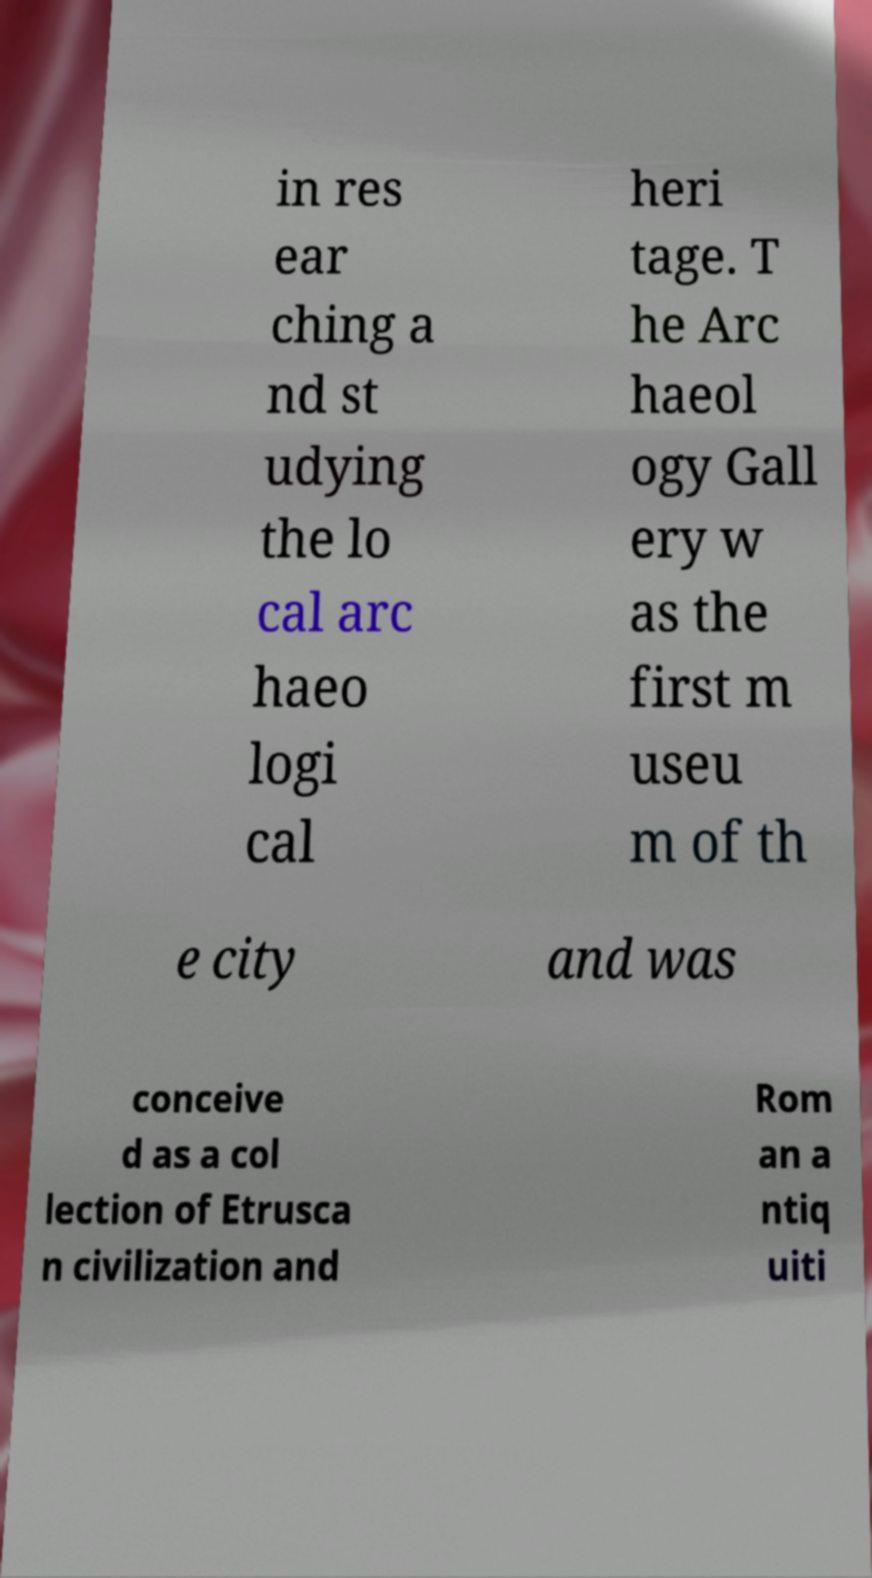I need the written content from this picture converted into text. Can you do that? in res ear ching a nd st udying the lo cal arc haeo logi cal heri tage. T he Arc haeol ogy Gall ery w as the first m useu m of th e city and was conceive d as a col lection of Etrusca n civilization and Rom an a ntiq uiti 